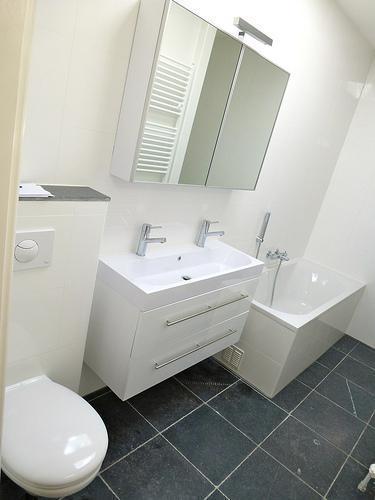How many faucets does the sink have?
Give a very brief answer. 2. How many people are in this photograph?
Give a very brief answer. 0. How many toilets are in the photograph?
Give a very brief answer. 2. 